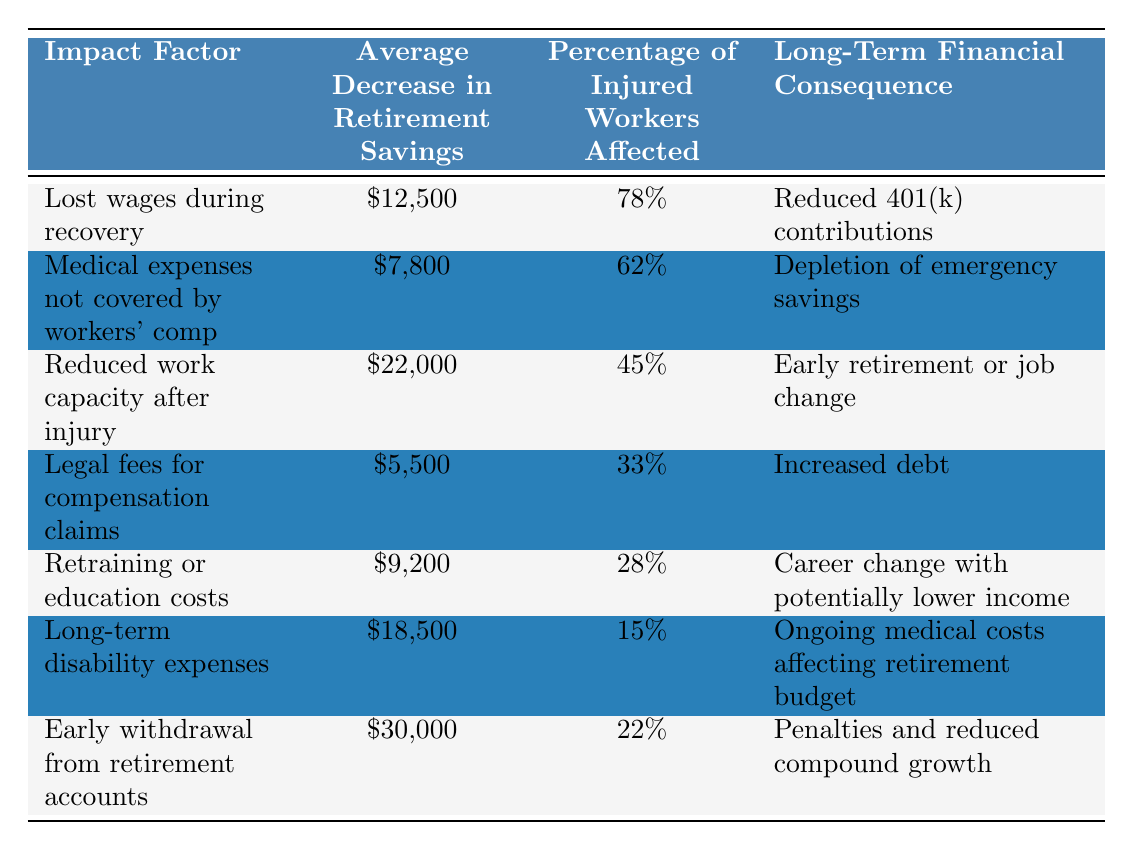What is the average decrease in retirement savings due to lost wages during recovery? The table shows that the average decrease in retirement savings from lost wages during recovery is $12,500.
Answer: $12,500 Which impact factor has the highest average decrease in retirement savings? By comparing all the average decreases listed in the table, "Early withdrawal from retirement accounts" has the highest average decrease at $30,000.
Answer: Early withdrawal from retirement accounts What percentage of injured workers are affected by legal fees for compensation claims? The table indicates that 33% of injured workers are affected by legal fees for compensation claims.
Answer: 33% What is the total average decrease in retirement savings for lost wages during recovery and long-term disability expenses combined? To find the total, add the average decreases: $12,500 (lost wages) + $18,500 (long-term disability) = $31,000.
Answer: $31,000 Are more injured workers affected by medical expenses not covered by workers' compensation or by retraining or education costs? From the table, 62% of injured workers are affected by medical expenses not covered, while 28% are affected by retraining or education costs. Since 62% is greater than 28%, more workers are affected by medical expenses.
Answer: Yes, more workers are affected by medical expenses What is the combined average decrease in retirement savings from medical expenses not covered by workers' compensation and legal fees? Add the averages: $7,800 (medical expenses) + $5,500 (legal fees) = $13,300.
Answer: $13,300 Which financial consequence corresponds with the "Reduced work capacity after injury"? The table shows that the financial consequence of reduced work capacity after injury is "Early retirement or job change."
Answer: Early retirement or job change Is it true that 22% of injured workers are affected by early withdrawal from retirement accounts? The table states that the percentage affected by early withdrawal is indeed 22%. Therefore, this statement is true.
Answer: True What is the average decrease in retirement savings associated with reduced work capacity after injury compared to lost wages during recovery? The average decrease for reduced work capacity is $22,000, while for lost wages, it is $12,500. Comparing these, $22,000 - $12,500 = $9,500 higher for reduced work capacity.
Answer: $9,500 higher What percentage of injured workers affected by early withdrawal from retirement accounts also experience long-term disability expenses? The percentage of affected workers for early withdrawal is 22% and for long-term disability expenses it is 15%. The question does not imply a direct correlation, so we cannot claim a specific overlap.
Answer: Not applicable How many impact factors listed have an average decrease in retirement savings greater than $10,000? The factors with average decreases greater than $10,000 are: reduced work capacity ($22,000), long-term disability expenses ($18,500), and early withdrawal ($30,000). This makes a total of three impact factors.
Answer: 3 